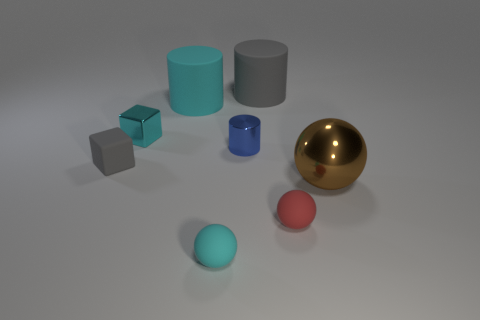How many other things are there of the same color as the metallic cylinder?
Offer a very short reply. 0. Are there more tiny cyan matte objects left of the rubber cube than small blue blocks?
Your response must be concise. No. The tiny matte thing right of the rubber cylinder that is to the right of the cyan matte object that is in front of the big cyan cylinder is what color?
Keep it short and to the point. Red. Is the material of the tiny cyan block the same as the tiny cylinder?
Your answer should be very brief. Yes. Is there a cylinder of the same size as the cyan metal thing?
Your answer should be very brief. Yes. There is a cylinder that is the same size as the cyan block; what is its material?
Your answer should be compact. Metal. Are there an equal number of small cyan metallic cylinders and small things?
Make the answer very short. No. Is there a blue shiny object of the same shape as the big gray object?
Ensure brevity in your answer.  Yes. There is a object that is the same color as the rubber cube; what is its material?
Your response must be concise. Rubber. The tiny cyan thing in front of the tiny gray rubber object has what shape?
Offer a terse response. Sphere. 